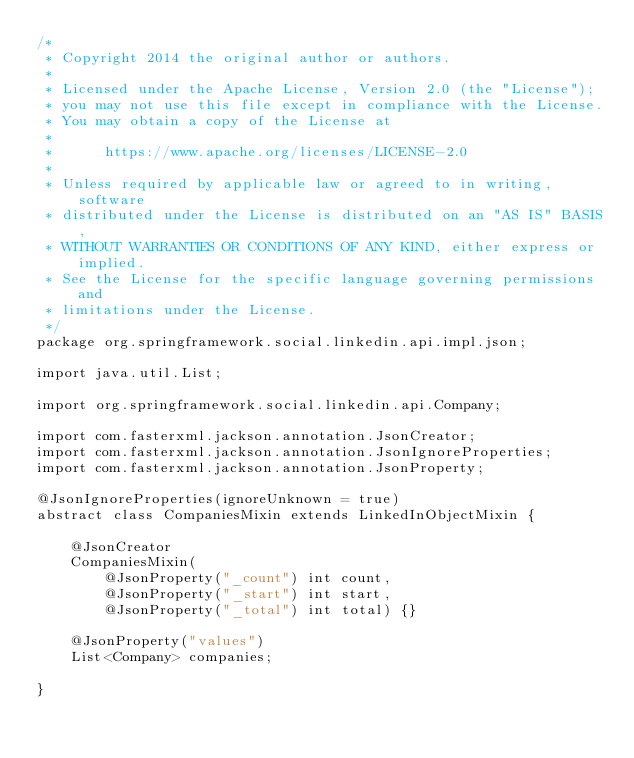Convert code to text. <code><loc_0><loc_0><loc_500><loc_500><_Java_>/*
 * Copyright 2014 the original author or authors.
 *
 * Licensed under the Apache License, Version 2.0 (the "License");
 * you may not use this file except in compliance with the License.
 * You may obtain a copy of the License at
 *
 *      https://www.apache.org/licenses/LICENSE-2.0
 *
 * Unless required by applicable law or agreed to in writing, software
 * distributed under the License is distributed on an "AS IS" BASIS,
 * WITHOUT WARRANTIES OR CONDITIONS OF ANY KIND, either express or implied.
 * See the License for the specific language governing permissions and
 * limitations under the License.
 */
package org.springframework.social.linkedin.api.impl.json;

import java.util.List;

import org.springframework.social.linkedin.api.Company;

import com.fasterxml.jackson.annotation.JsonCreator;
import com.fasterxml.jackson.annotation.JsonIgnoreProperties;
import com.fasterxml.jackson.annotation.JsonProperty;

@JsonIgnoreProperties(ignoreUnknown = true)
abstract class CompaniesMixin extends LinkedInObjectMixin {
	
	@JsonCreator
	CompaniesMixin(
		@JsonProperty("_count") int count, 
		@JsonProperty("_start") int start, 
		@JsonProperty("_total") int total) {}
	
	@JsonProperty("values") 
	List<Company> companies;

}
</code> 